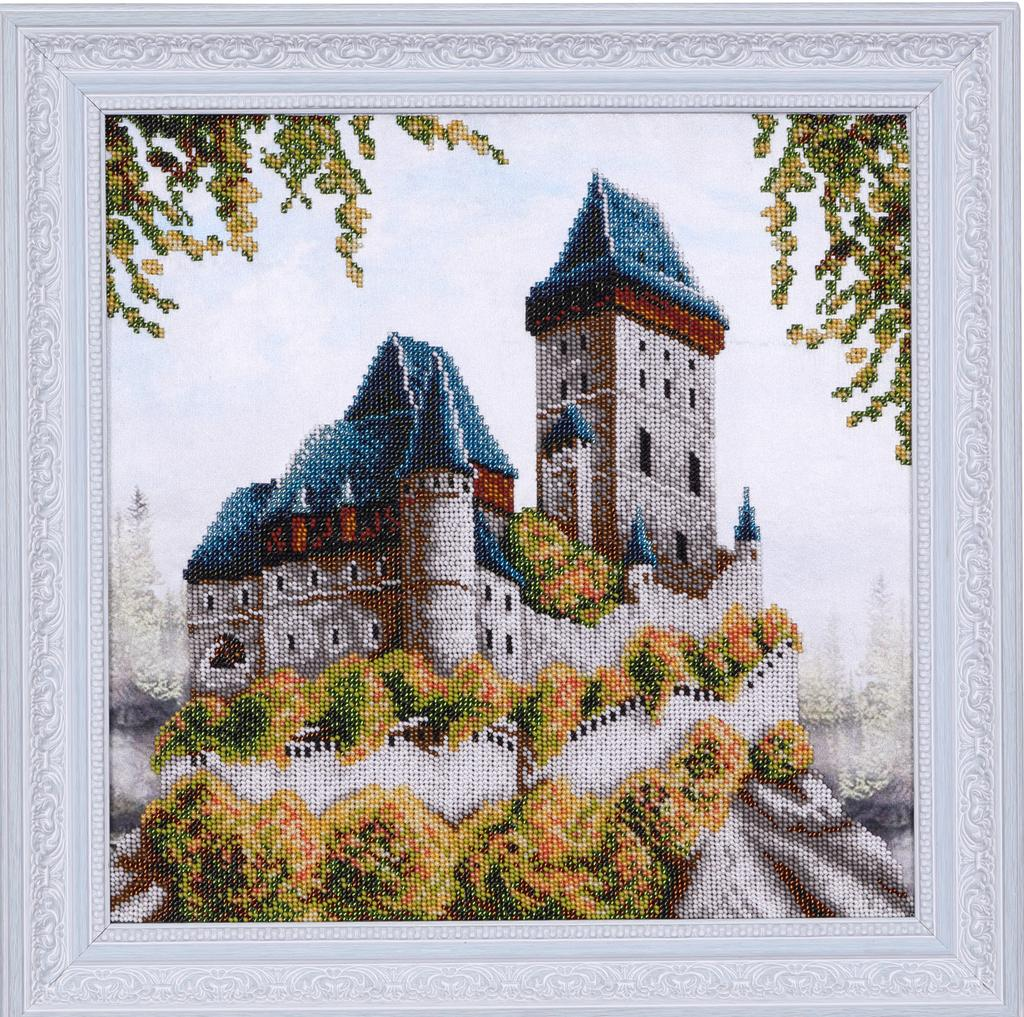What is the main subject of the image? The main subject of the image is a frame of a house. How many frogs can be seen wearing collars in the image? There are no frogs or collars present in the image; it features a frame of a house. 